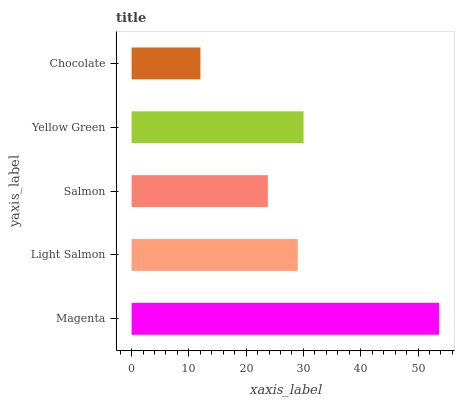Is Chocolate the minimum?
Answer yes or no. Yes. Is Magenta the maximum?
Answer yes or no. Yes. Is Light Salmon the minimum?
Answer yes or no. No. Is Light Salmon the maximum?
Answer yes or no. No. Is Magenta greater than Light Salmon?
Answer yes or no. Yes. Is Light Salmon less than Magenta?
Answer yes or no. Yes. Is Light Salmon greater than Magenta?
Answer yes or no. No. Is Magenta less than Light Salmon?
Answer yes or no. No. Is Light Salmon the high median?
Answer yes or no. Yes. Is Light Salmon the low median?
Answer yes or no. Yes. Is Magenta the high median?
Answer yes or no. No. Is Chocolate the low median?
Answer yes or no. No. 